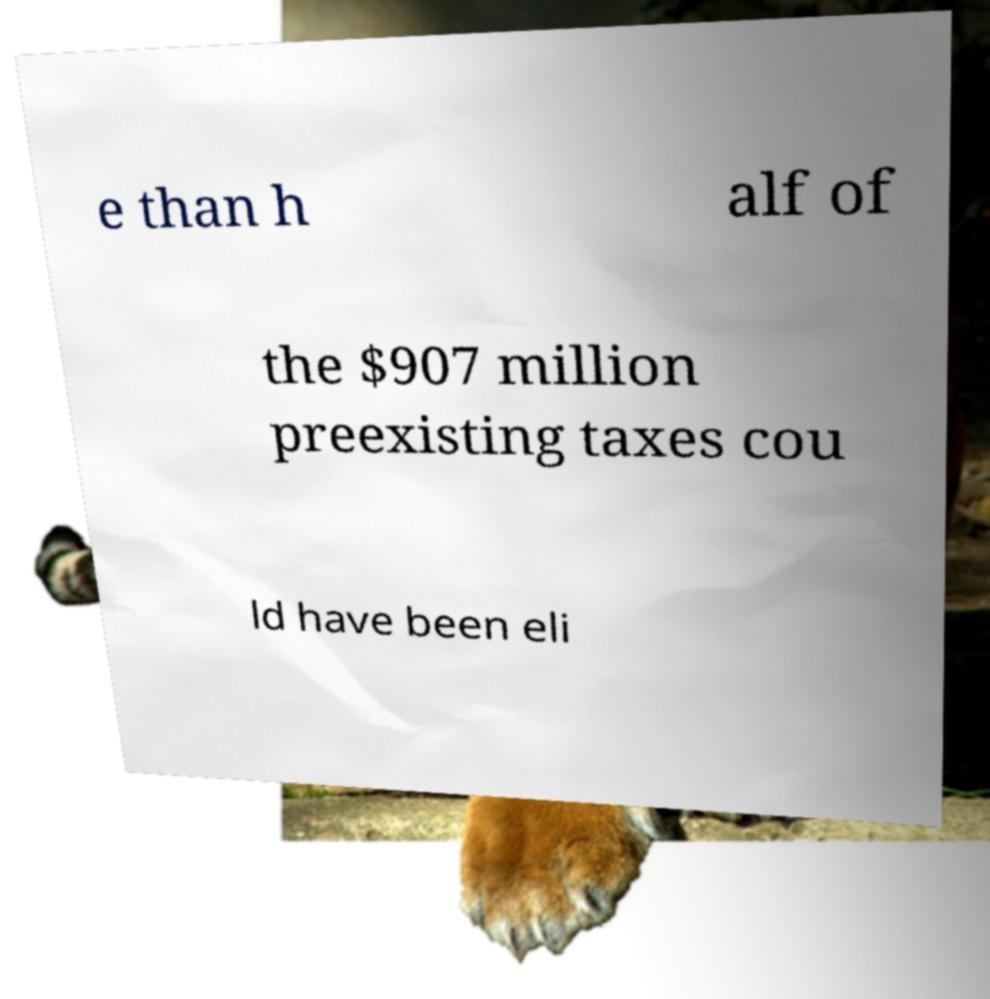What messages or text are displayed in this image? I need them in a readable, typed format. e than h alf of the $907 million preexisting taxes cou ld have been eli 